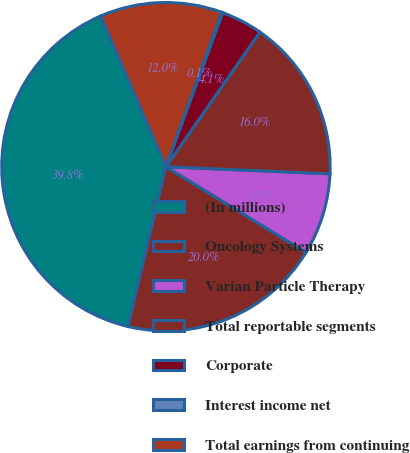Convert chart to OTSL. <chart><loc_0><loc_0><loc_500><loc_500><pie_chart><fcel>(In millions)<fcel>Oncology Systems<fcel>Varian Particle Therapy<fcel>Total reportable segments<fcel>Corporate<fcel>Interest income net<fcel>Total earnings from continuing<nl><fcel>39.8%<fcel>19.96%<fcel>8.05%<fcel>15.99%<fcel>4.08%<fcel>0.11%<fcel>12.02%<nl></chart> 